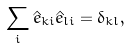<formula> <loc_0><loc_0><loc_500><loc_500>\sum _ { i } \hat { e } _ { k i } \hat { e } _ { l i } = \delta _ { k l } ,</formula> 